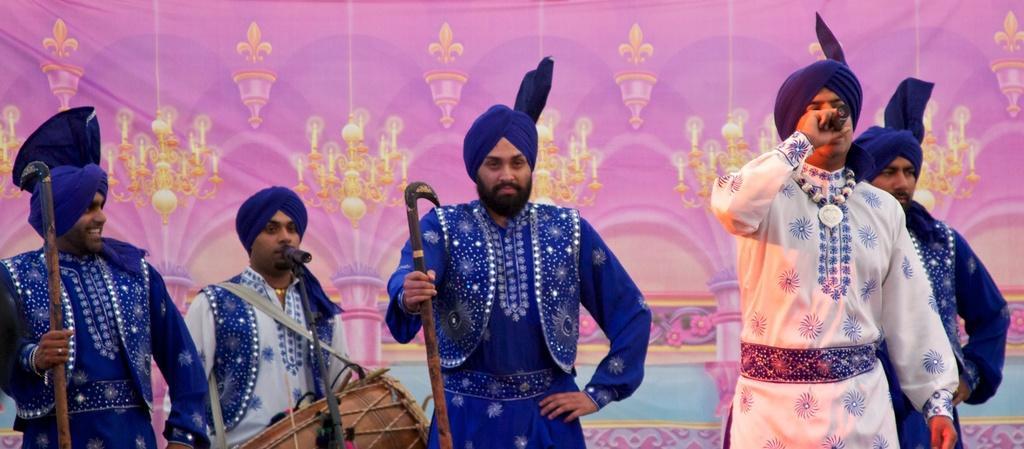Could you give a brief overview of what you see in this image? In this image, we can see people wearing costumes and are holding sticks and one of them is holding a mic and we can see a person wearing a drum. In the background, there is a banner and we can see a mic stand. 